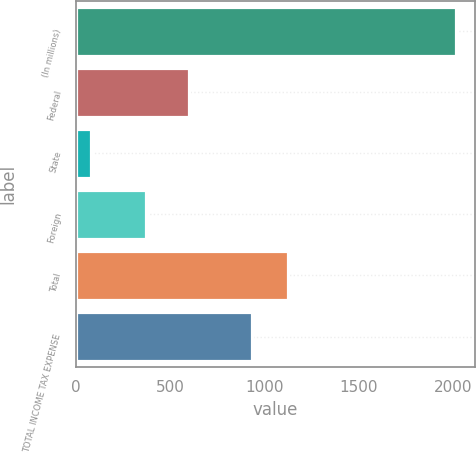<chart> <loc_0><loc_0><loc_500><loc_500><bar_chart><fcel>(In millions)<fcel>Federal<fcel>State<fcel>Foreign<fcel>Total<fcel>TOTAL INCOME TAX EXPENSE<nl><fcel>2015<fcel>596<fcel>80<fcel>369<fcel>1125.5<fcel>932<nl></chart> 